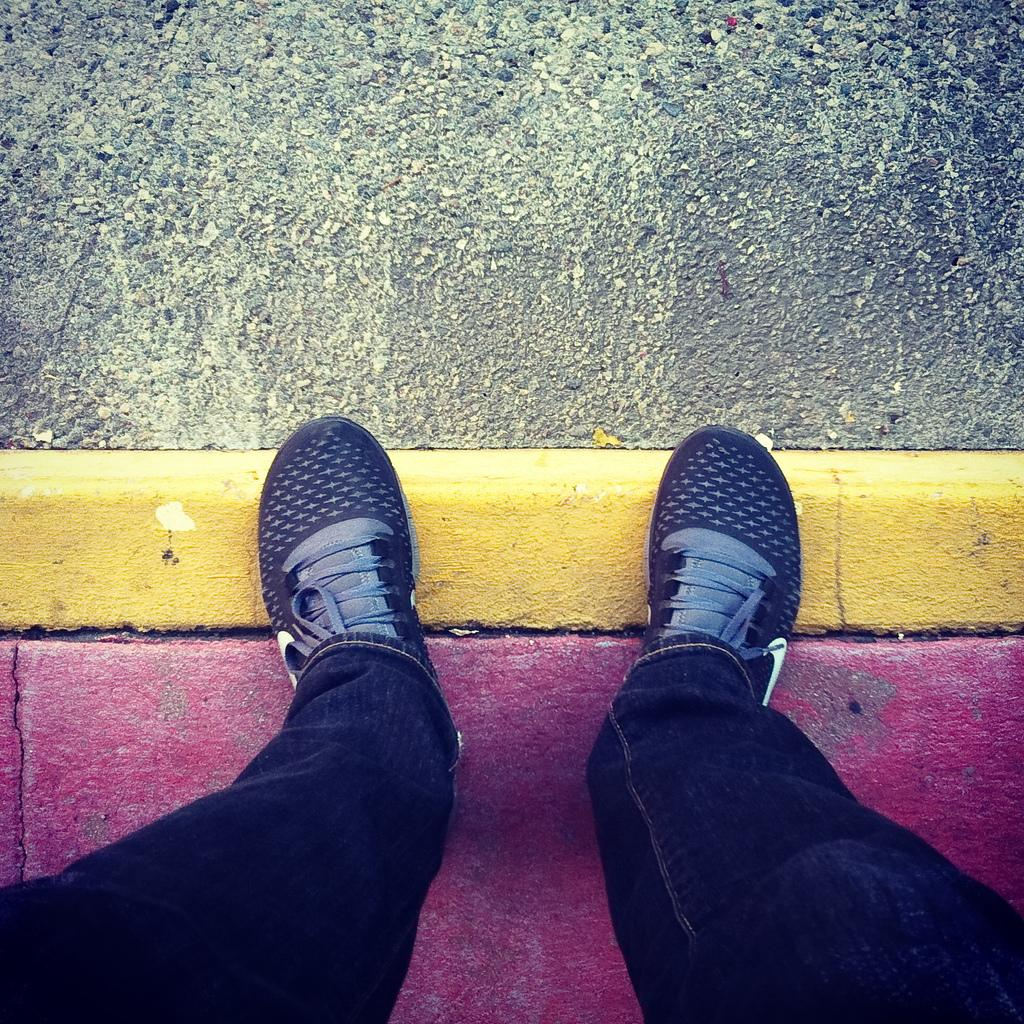What part of a person can be seen in the image? There are legs of a person in the image. What type of footwear is the person wearing? The person is wearing shoes. What can be observed on the surface in the image? There are colors visible on the surface in the image. What type of leaf can be seen in the image? There is no leaf present in the image. Does the person have a tail in the image? There is no tail visible in the image. 